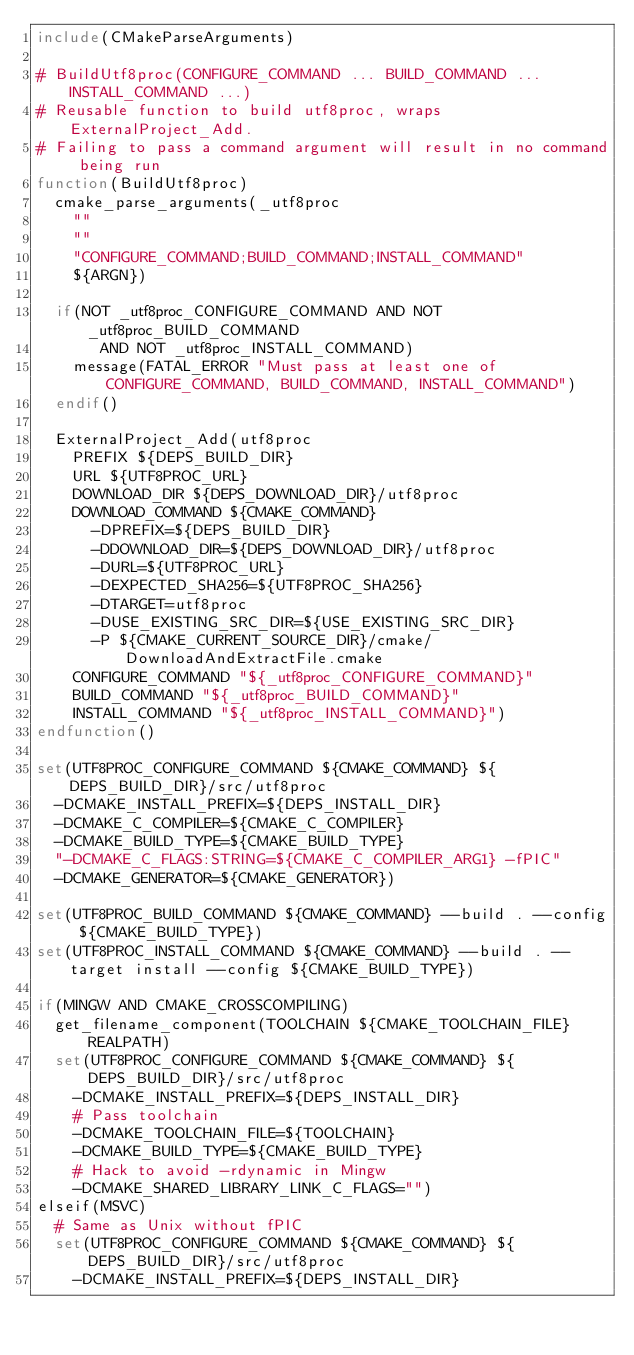<code> <loc_0><loc_0><loc_500><loc_500><_CMake_>include(CMakeParseArguments)

# BuildUtf8proc(CONFIGURE_COMMAND ... BUILD_COMMAND ... INSTALL_COMMAND ...)
# Reusable function to build utf8proc, wraps ExternalProject_Add.
# Failing to pass a command argument will result in no command being run
function(BuildUtf8proc)
  cmake_parse_arguments(_utf8proc
    ""
    ""
    "CONFIGURE_COMMAND;BUILD_COMMAND;INSTALL_COMMAND"
    ${ARGN})

  if(NOT _utf8proc_CONFIGURE_COMMAND AND NOT _utf8proc_BUILD_COMMAND
       AND NOT _utf8proc_INSTALL_COMMAND)
    message(FATAL_ERROR "Must pass at least one of CONFIGURE_COMMAND, BUILD_COMMAND, INSTALL_COMMAND")
  endif()

  ExternalProject_Add(utf8proc
    PREFIX ${DEPS_BUILD_DIR}
    URL ${UTF8PROC_URL}
    DOWNLOAD_DIR ${DEPS_DOWNLOAD_DIR}/utf8proc
    DOWNLOAD_COMMAND ${CMAKE_COMMAND}
      -DPREFIX=${DEPS_BUILD_DIR}
      -DDOWNLOAD_DIR=${DEPS_DOWNLOAD_DIR}/utf8proc
      -DURL=${UTF8PROC_URL}
      -DEXPECTED_SHA256=${UTF8PROC_SHA256}
      -DTARGET=utf8proc
      -DUSE_EXISTING_SRC_DIR=${USE_EXISTING_SRC_DIR}
      -P ${CMAKE_CURRENT_SOURCE_DIR}/cmake/DownloadAndExtractFile.cmake
    CONFIGURE_COMMAND "${_utf8proc_CONFIGURE_COMMAND}"
    BUILD_COMMAND "${_utf8proc_BUILD_COMMAND}"
    INSTALL_COMMAND "${_utf8proc_INSTALL_COMMAND}")
endfunction()

set(UTF8PROC_CONFIGURE_COMMAND ${CMAKE_COMMAND} ${DEPS_BUILD_DIR}/src/utf8proc
  -DCMAKE_INSTALL_PREFIX=${DEPS_INSTALL_DIR}
  -DCMAKE_C_COMPILER=${CMAKE_C_COMPILER}
  -DCMAKE_BUILD_TYPE=${CMAKE_BUILD_TYPE}
  "-DCMAKE_C_FLAGS:STRING=${CMAKE_C_COMPILER_ARG1} -fPIC"
  -DCMAKE_GENERATOR=${CMAKE_GENERATOR})

set(UTF8PROC_BUILD_COMMAND ${CMAKE_COMMAND} --build . --config ${CMAKE_BUILD_TYPE})
set(UTF8PROC_INSTALL_COMMAND ${CMAKE_COMMAND} --build . --target install --config ${CMAKE_BUILD_TYPE})

if(MINGW AND CMAKE_CROSSCOMPILING)
  get_filename_component(TOOLCHAIN ${CMAKE_TOOLCHAIN_FILE} REALPATH)
  set(UTF8PROC_CONFIGURE_COMMAND ${CMAKE_COMMAND} ${DEPS_BUILD_DIR}/src/utf8proc
    -DCMAKE_INSTALL_PREFIX=${DEPS_INSTALL_DIR}
    # Pass toolchain
    -DCMAKE_TOOLCHAIN_FILE=${TOOLCHAIN}
    -DCMAKE_BUILD_TYPE=${CMAKE_BUILD_TYPE}
    # Hack to avoid -rdynamic in Mingw
    -DCMAKE_SHARED_LIBRARY_LINK_C_FLAGS="")
elseif(MSVC)
  # Same as Unix without fPIC
  set(UTF8PROC_CONFIGURE_COMMAND ${CMAKE_COMMAND} ${DEPS_BUILD_DIR}/src/utf8proc
    -DCMAKE_INSTALL_PREFIX=${DEPS_INSTALL_DIR}</code> 